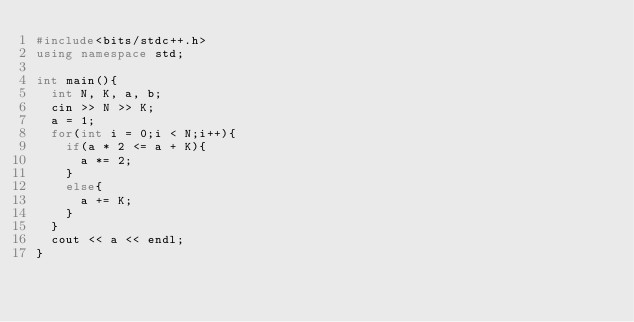<code> <loc_0><loc_0><loc_500><loc_500><_C++_>#include<bits/stdc++.h>
using namespace std;

int main(){
  int N, K, a, b;
  cin >> N >> K;
  a = 1;
  for(int i = 0;i < N;i++){
    if(a * 2 <= a + K){
      a *= 2;
    }
    else{
      a += K;
    }
  }
  cout << a << endl;
}</code> 